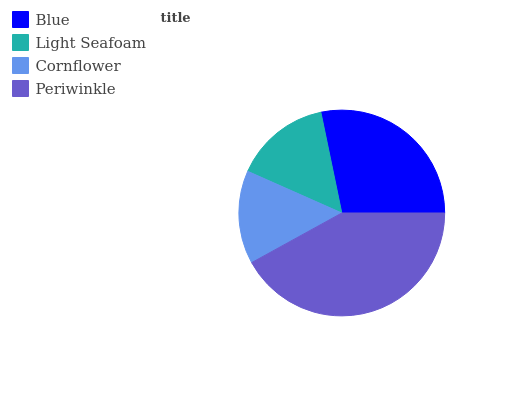Is Cornflower the minimum?
Answer yes or no. Yes. Is Periwinkle the maximum?
Answer yes or no. Yes. Is Light Seafoam the minimum?
Answer yes or no. No. Is Light Seafoam the maximum?
Answer yes or no. No. Is Blue greater than Light Seafoam?
Answer yes or no. Yes. Is Light Seafoam less than Blue?
Answer yes or no. Yes. Is Light Seafoam greater than Blue?
Answer yes or no. No. Is Blue less than Light Seafoam?
Answer yes or no. No. Is Blue the high median?
Answer yes or no. Yes. Is Light Seafoam the low median?
Answer yes or no. Yes. Is Cornflower the high median?
Answer yes or no. No. Is Blue the low median?
Answer yes or no. No. 